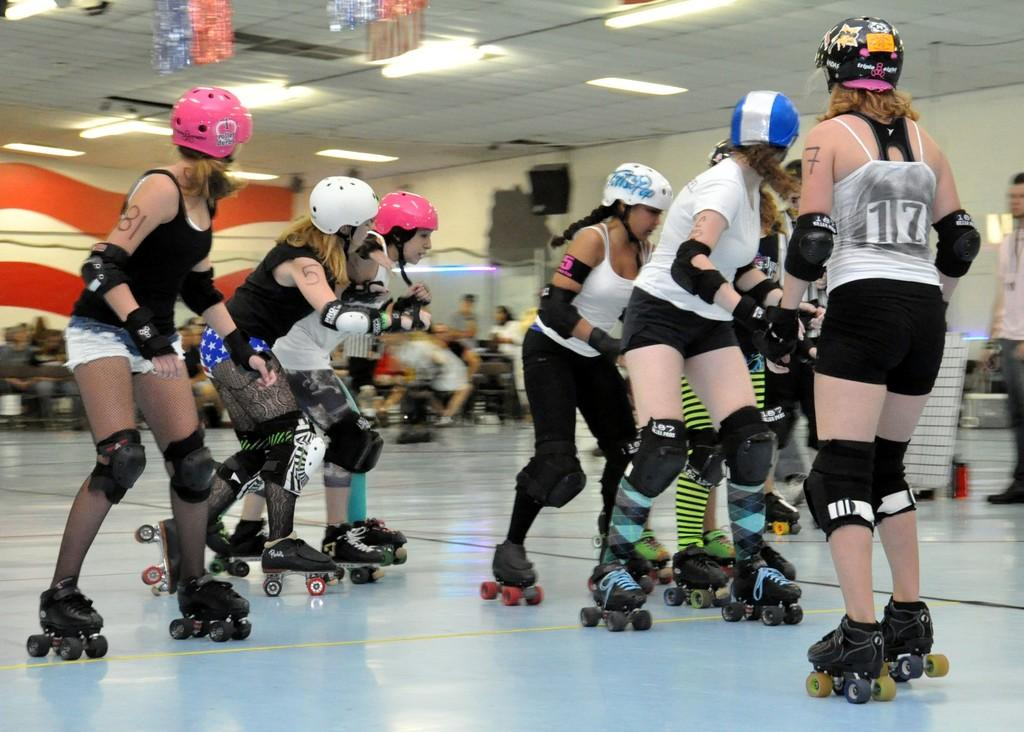What are the people in the image doing? The people in the image are skating. What are the people wearing on their heads? The people are wearing helmets. What type of shoes are the people wearing? The people are wearing skating shoes. What can be seen in the background of the image? There are other people and lights visible in the background. What type of view can be seen from the slope in the image? There is no slope present in the image, and therefore no view can be seen from it. 